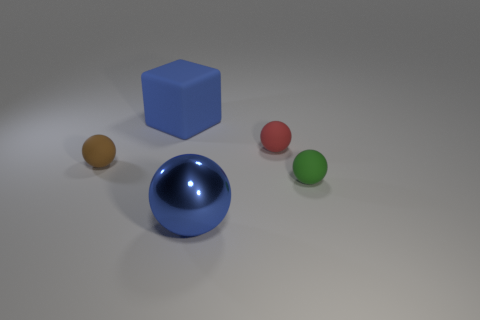Is there any indication of motion or activity in the scene? The image itself is static with no inherent indication of motion. The objects are at rest with distinct shadows grounded firmly on the surface, creating a sense of stillness and calm in the composition. 